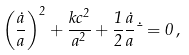<formula> <loc_0><loc_0><loc_500><loc_500>\left ( \frac { \dot { a } } { a } \right ) ^ { 2 } + \frac { k c ^ { 2 } } { a ^ { 2 } } + \frac { 1 } { 2 } \frac { \dot { a } } { a } \dot { \mu } = 0 \, ,</formula> 